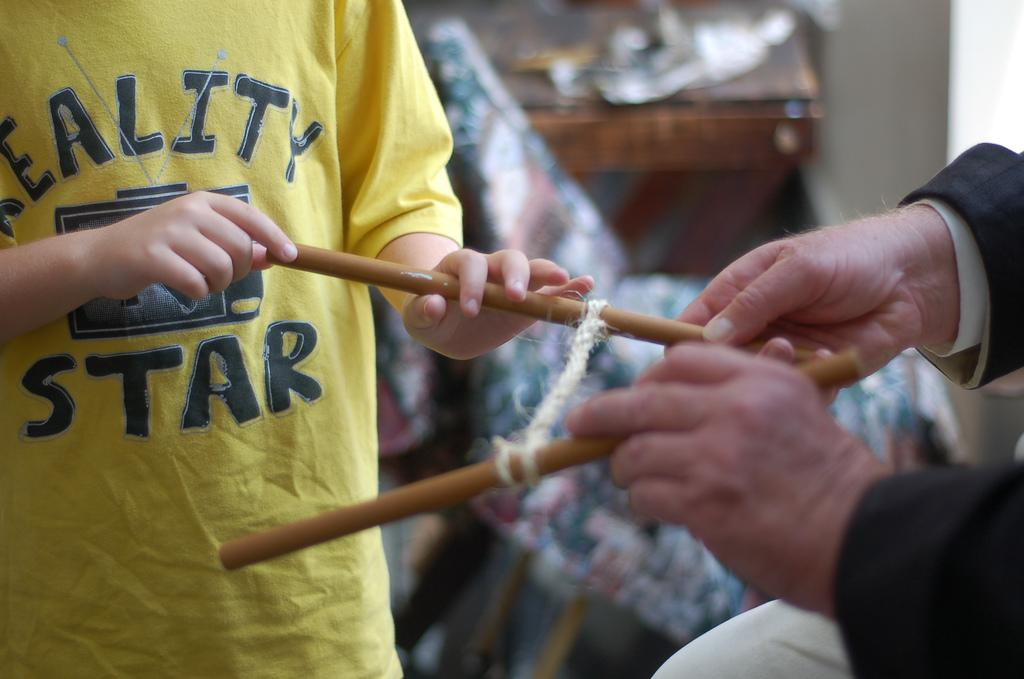<image>
Offer a succinct explanation of the picture presented. A child wearing a shirt that says 'Reality Star' holding sticks. 